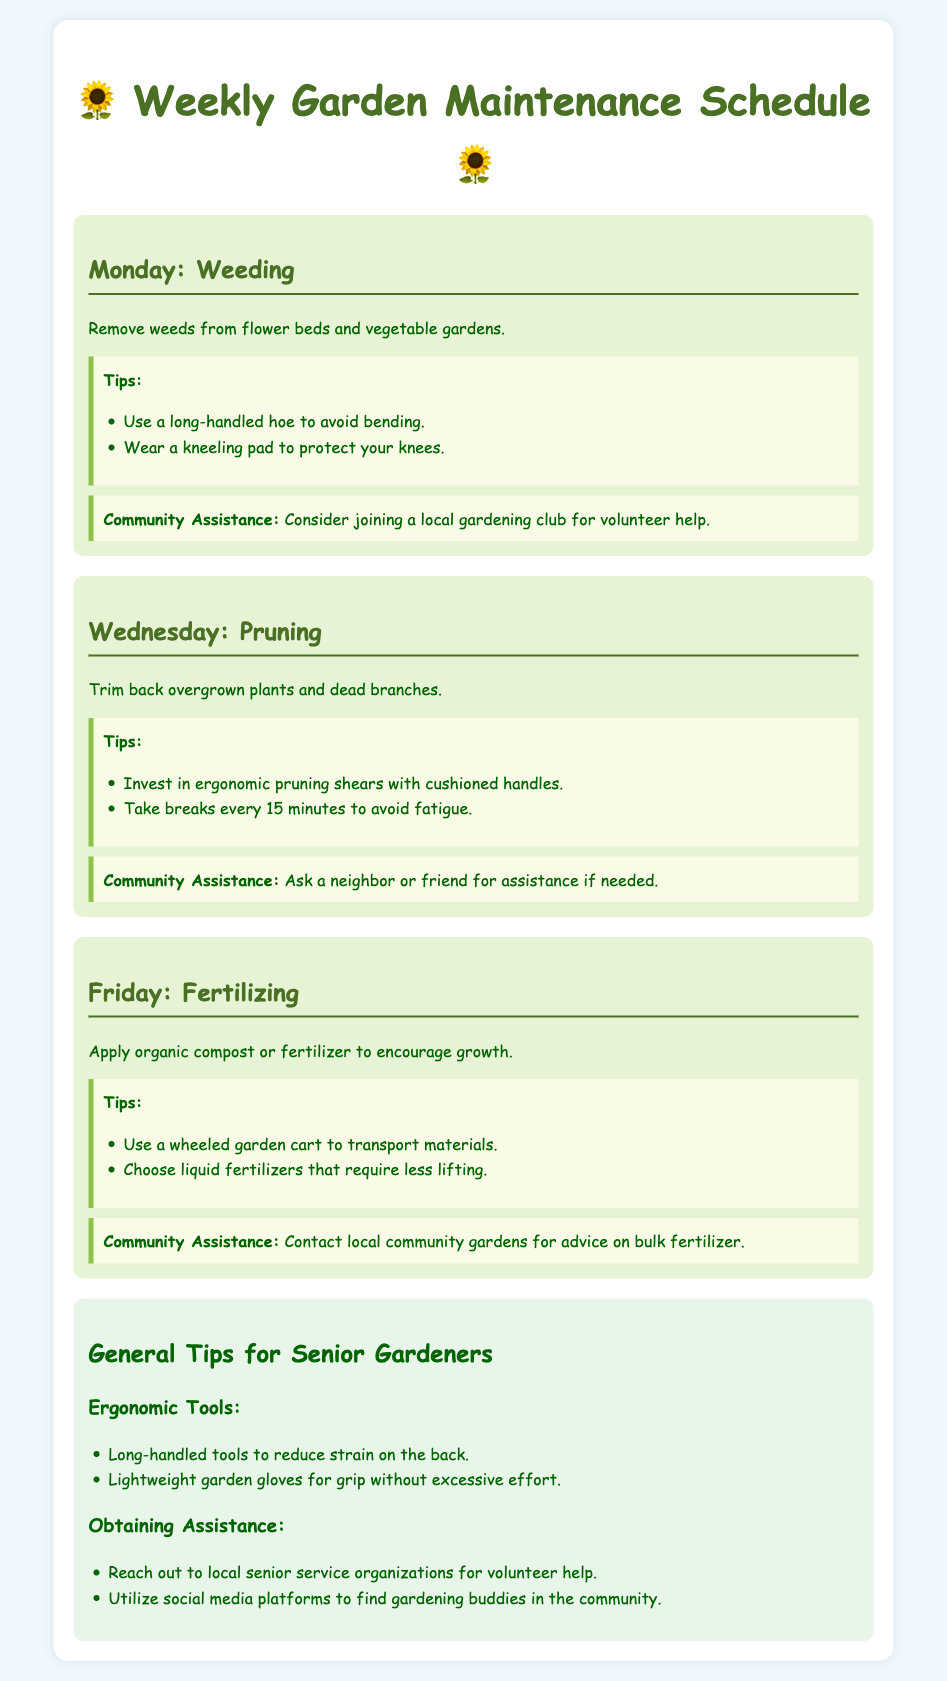what task is scheduled for Monday? The document specifies "Weeding" as the task for Monday.
Answer: Weeding what ergonomic tool is recommended for pruning? The document suggests using "ergonomic pruning shears with cushioned handles."
Answer: ergonomic pruning shears how often should breaks be taken when pruning? The document states that breaks should be taken every "15 minutes" to avoid fatigue.
Answer: 15 minutes what type of fertilizer should be used on Friday? The document recommends using "organic compost or fertilizer" for fertilizing.
Answer: organic compost what community resource can help with heavy lifting? The document mentions "local senior service organizations" as a resource for volunteer help.
Answer: local senior service organizations what is suggested to protect knees while weeding? The document advises wearing a "kneeling pad" to protect the knees while weeding.
Answer: kneeling pad how can you transport fertilizer easily? The document suggests using a "wheeled garden cart" to transport materials for fertilizing.
Answer: wheeled garden cart what color scheme is used for the document's background? The document has a light blue background color, which is described as "#f0f8ff."
Answer: light blue which day is focused on applying fertilizer? The document indicates that "Friday" is the day to apply fertilizer.
Answer: Friday 